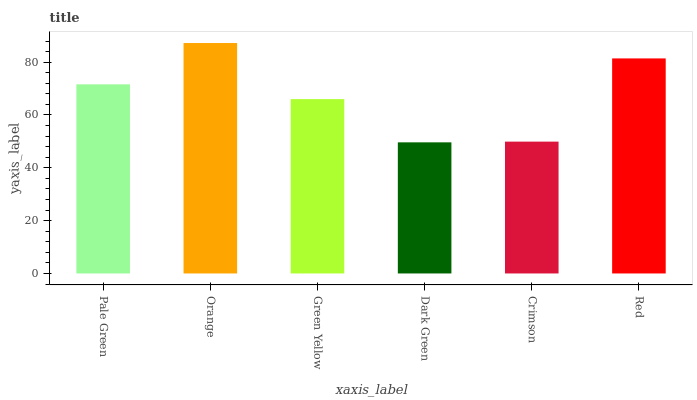Is Dark Green the minimum?
Answer yes or no. Yes. Is Orange the maximum?
Answer yes or no. Yes. Is Green Yellow the minimum?
Answer yes or no. No. Is Green Yellow the maximum?
Answer yes or no. No. Is Orange greater than Green Yellow?
Answer yes or no. Yes. Is Green Yellow less than Orange?
Answer yes or no. Yes. Is Green Yellow greater than Orange?
Answer yes or no. No. Is Orange less than Green Yellow?
Answer yes or no. No. Is Pale Green the high median?
Answer yes or no. Yes. Is Green Yellow the low median?
Answer yes or no. Yes. Is Red the high median?
Answer yes or no. No. Is Pale Green the low median?
Answer yes or no. No. 